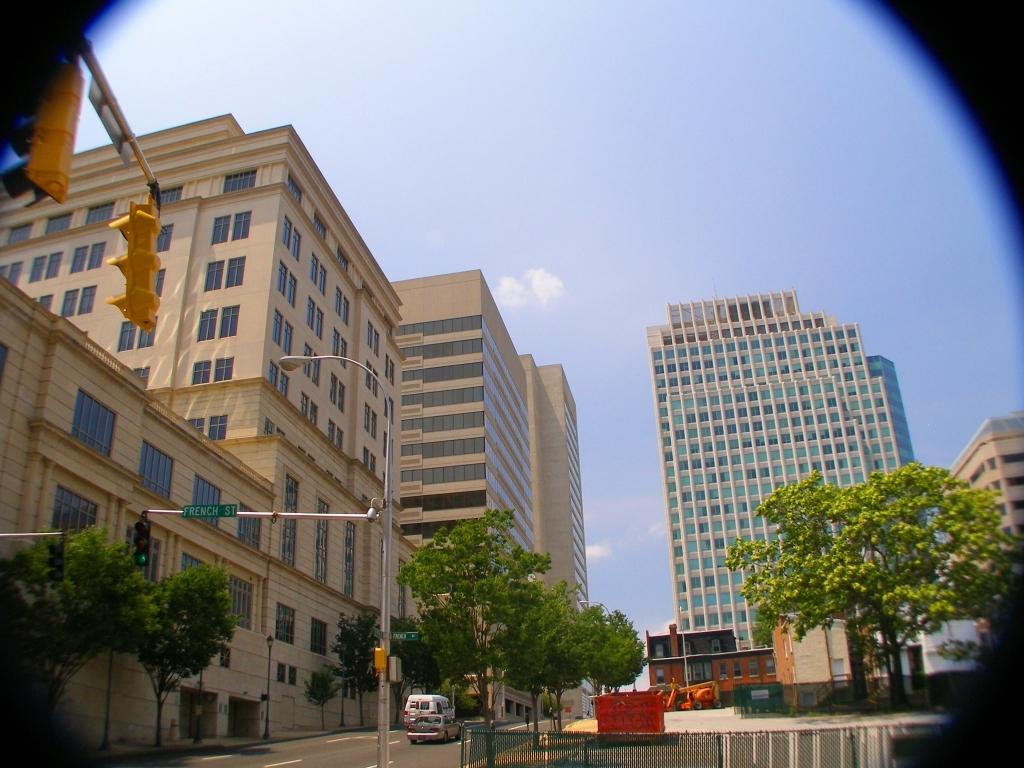What is the main feature of the image? There is a road in the image. What can be seen on the road? There are vehicles on the road. What structures are present near the road? There is a railing, a pole, and traffic signals in the image. What other objects can be seen in the image? There is a board and trees in the image. What type of structures are visible in the background? There are buildings in the image. What is visible in the background of the image? The sky is visible in the background of the image. How many knots are tied on the board in the image? There are no knots present on the board in the image. Can you touch the sky in the image? The sky is not a tangible object, so it cannot be touched in the image. 